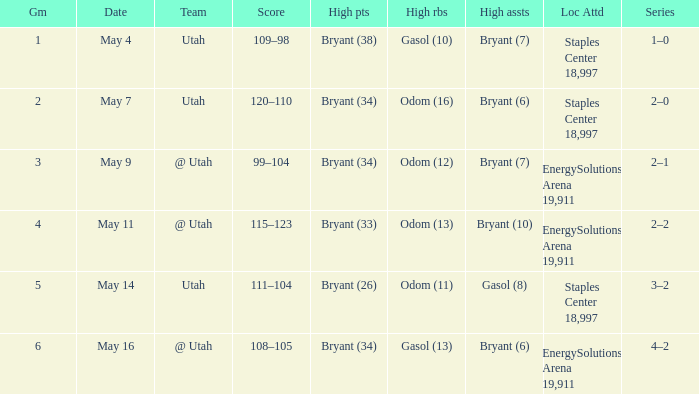What is the High rebounds with a Series with 4–2? Gasol (13). 